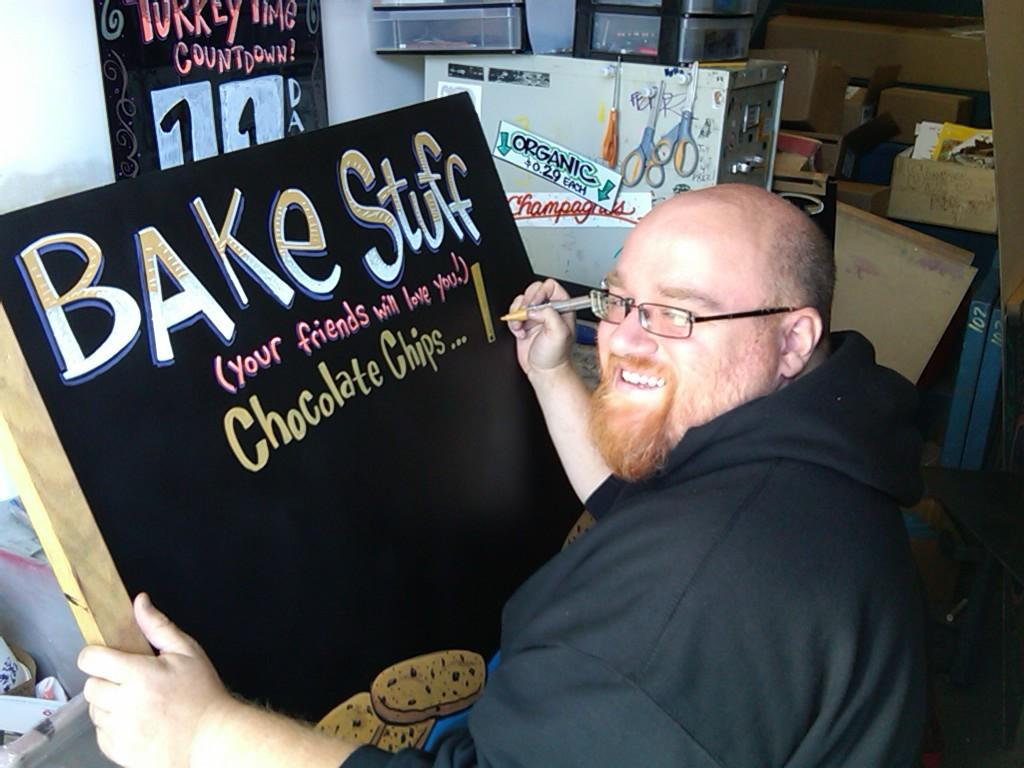<image>
Present a compact description of the photo's key features. A man with glasses is writing on a blackboard that says Bake Stuff. 